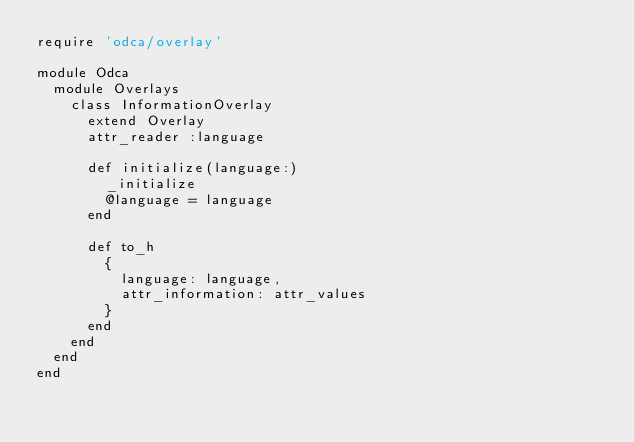<code> <loc_0><loc_0><loc_500><loc_500><_Ruby_>require 'odca/overlay'

module Odca
  module Overlays
    class InformationOverlay
      extend Overlay
      attr_reader :language

      def initialize(language:)
        _initialize
        @language = language
      end

      def to_h
        {
          language: language,
          attr_information: attr_values
        }
      end
    end
  end
end
</code> 